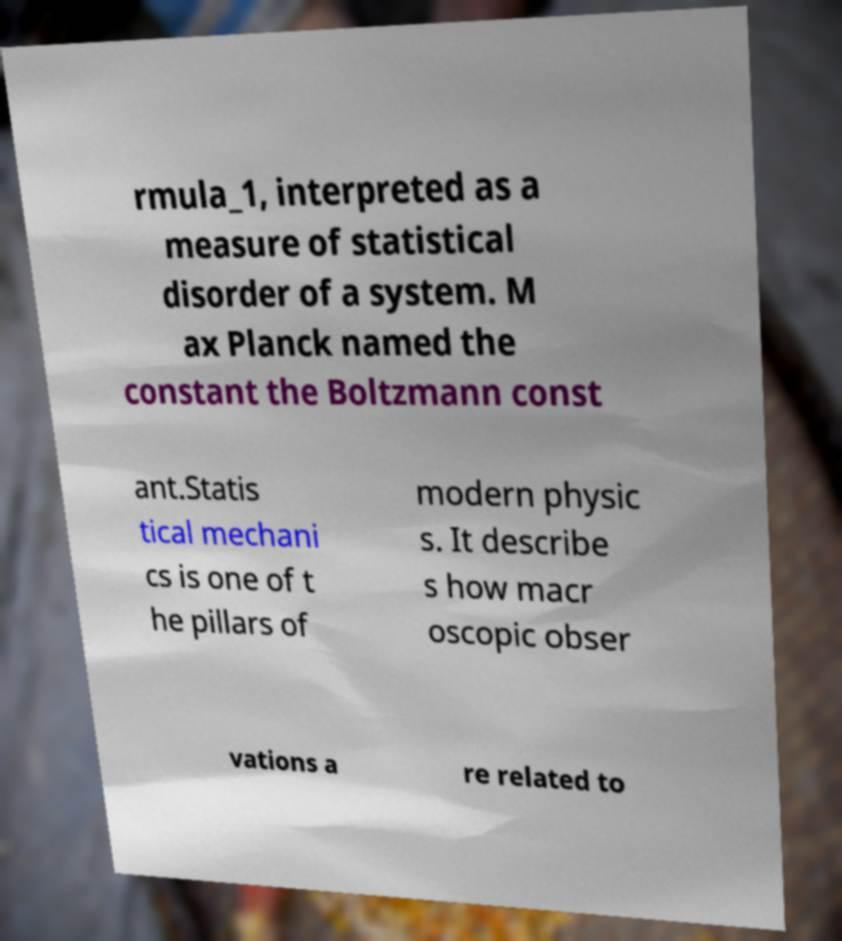Could you assist in decoding the text presented in this image and type it out clearly? rmula_1, interpreted as a measure of statistical disorder of a system. M ax Planck named the constant the Boltzmann const ant.Statis tical mechani cs is one of t he pillars of modern physic s. It describe s how macr oscopic obser vations a re related to 